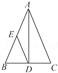Elucidate the elements visible in the diagram. The diagram consists of a triangle ABC with vertices A, B, and C. Point D is the altitude from point A to side BC, and point E is the midpoint of side AB. 